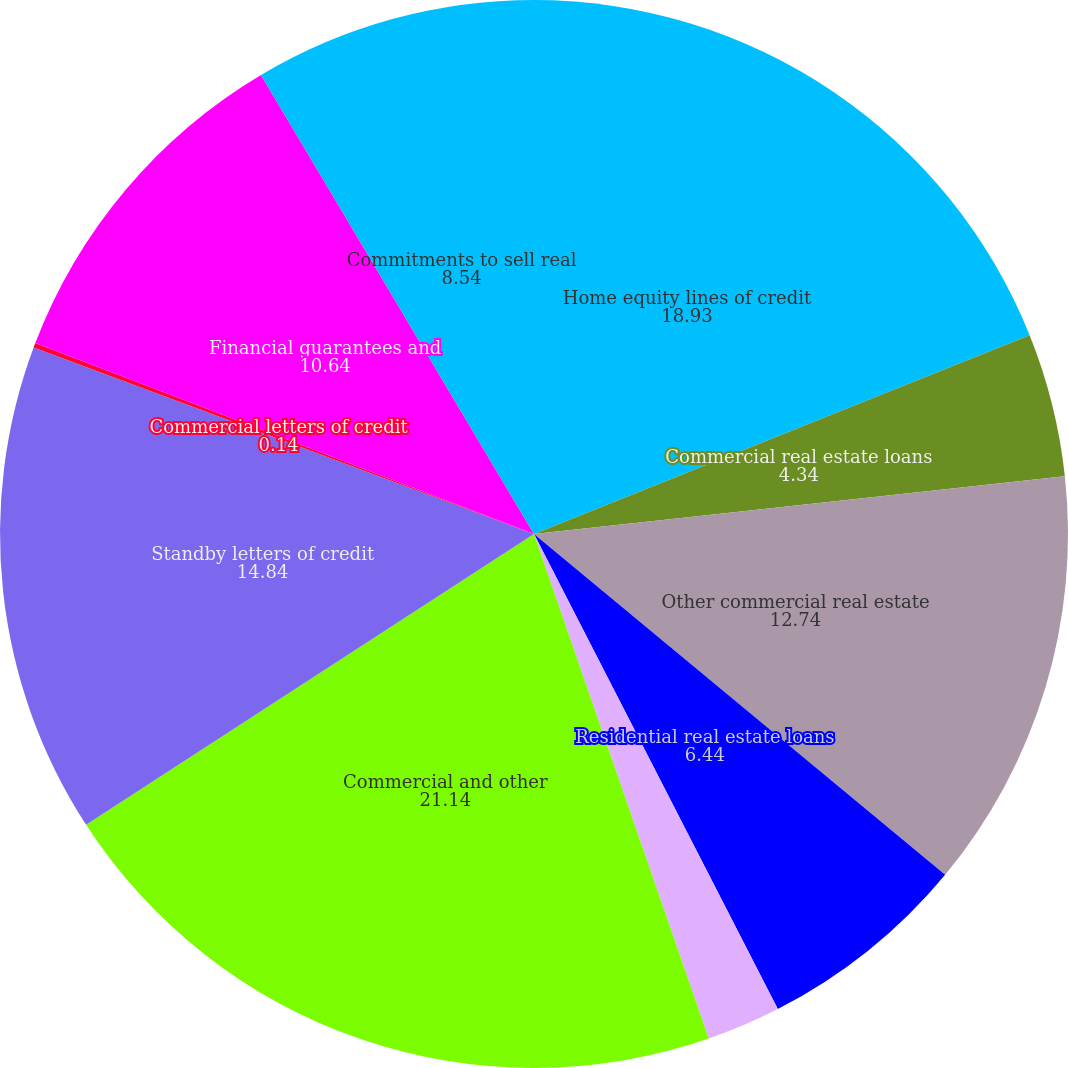Convert chart to OTSL. <chart><loc_0><loc_0><loc_500><loc_500><pie_chart><fcel>Home equity lines of credit<fcel>Commercial real estate loans<fcel>Other commercial real estate<fcel>Residential real estate loans<fcel>Other residential real estate<fcel>Commercial and other<fcel>Standby letters of credit<fcel>Commercial letters of credit<fcel>Financial guarantees and<fcel>Commitments to sell real<nl><fcel>18.93%<fcel>4.34%<fcel>12.74%<fcel>6.44%<fcel>2.24%<fcel>21.14%<fcel>14.84%<fcel>0.14%<fcel>10.64%<fcel>8.54%<nl></chart> 